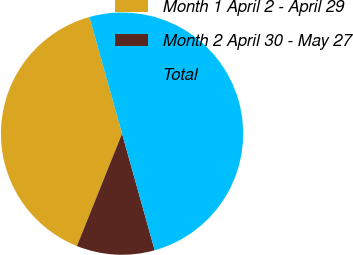<chart> <loc_0><loc_0><loc_500><loc_500><pie_chart><fcel>Month 1 April 2 - April 29<fcel>Month 2 April 30 - May 27<fcel>Total<nl><fcel>39.58%<fcel>10.42%<fcel>50.0%<nl></chart> 